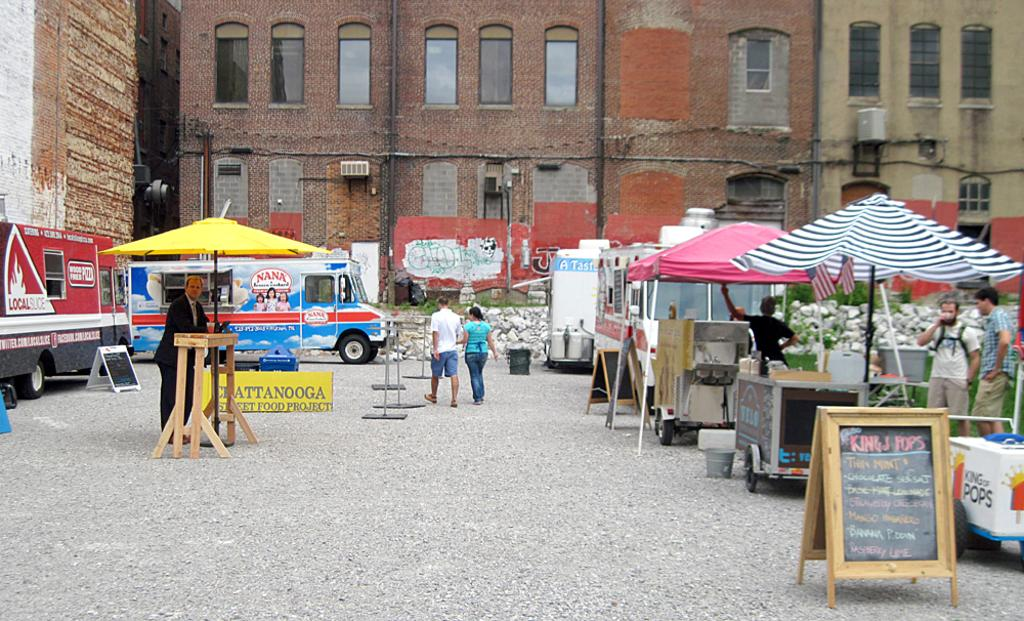What objects can be seen in the middle of the image? There are umbrellas, banners, tables, vehicles, and people standing and walking in the middle of the image. What type of event might be taking place based on the presence of these objects? It is difficult to determine the specific event, but it appears to be a gathering or celebration with various elements such as tables, banners, and people. What structures are visible at the top of the image? There are buildings visible at the top of the image. How many pizzas are being delivered by the passenger in the image? There are no pizzas or passengers present in the image. What type of steam is visible coming from the vehicles in the image? There is no steam visible coming from the vehicles in the image. 